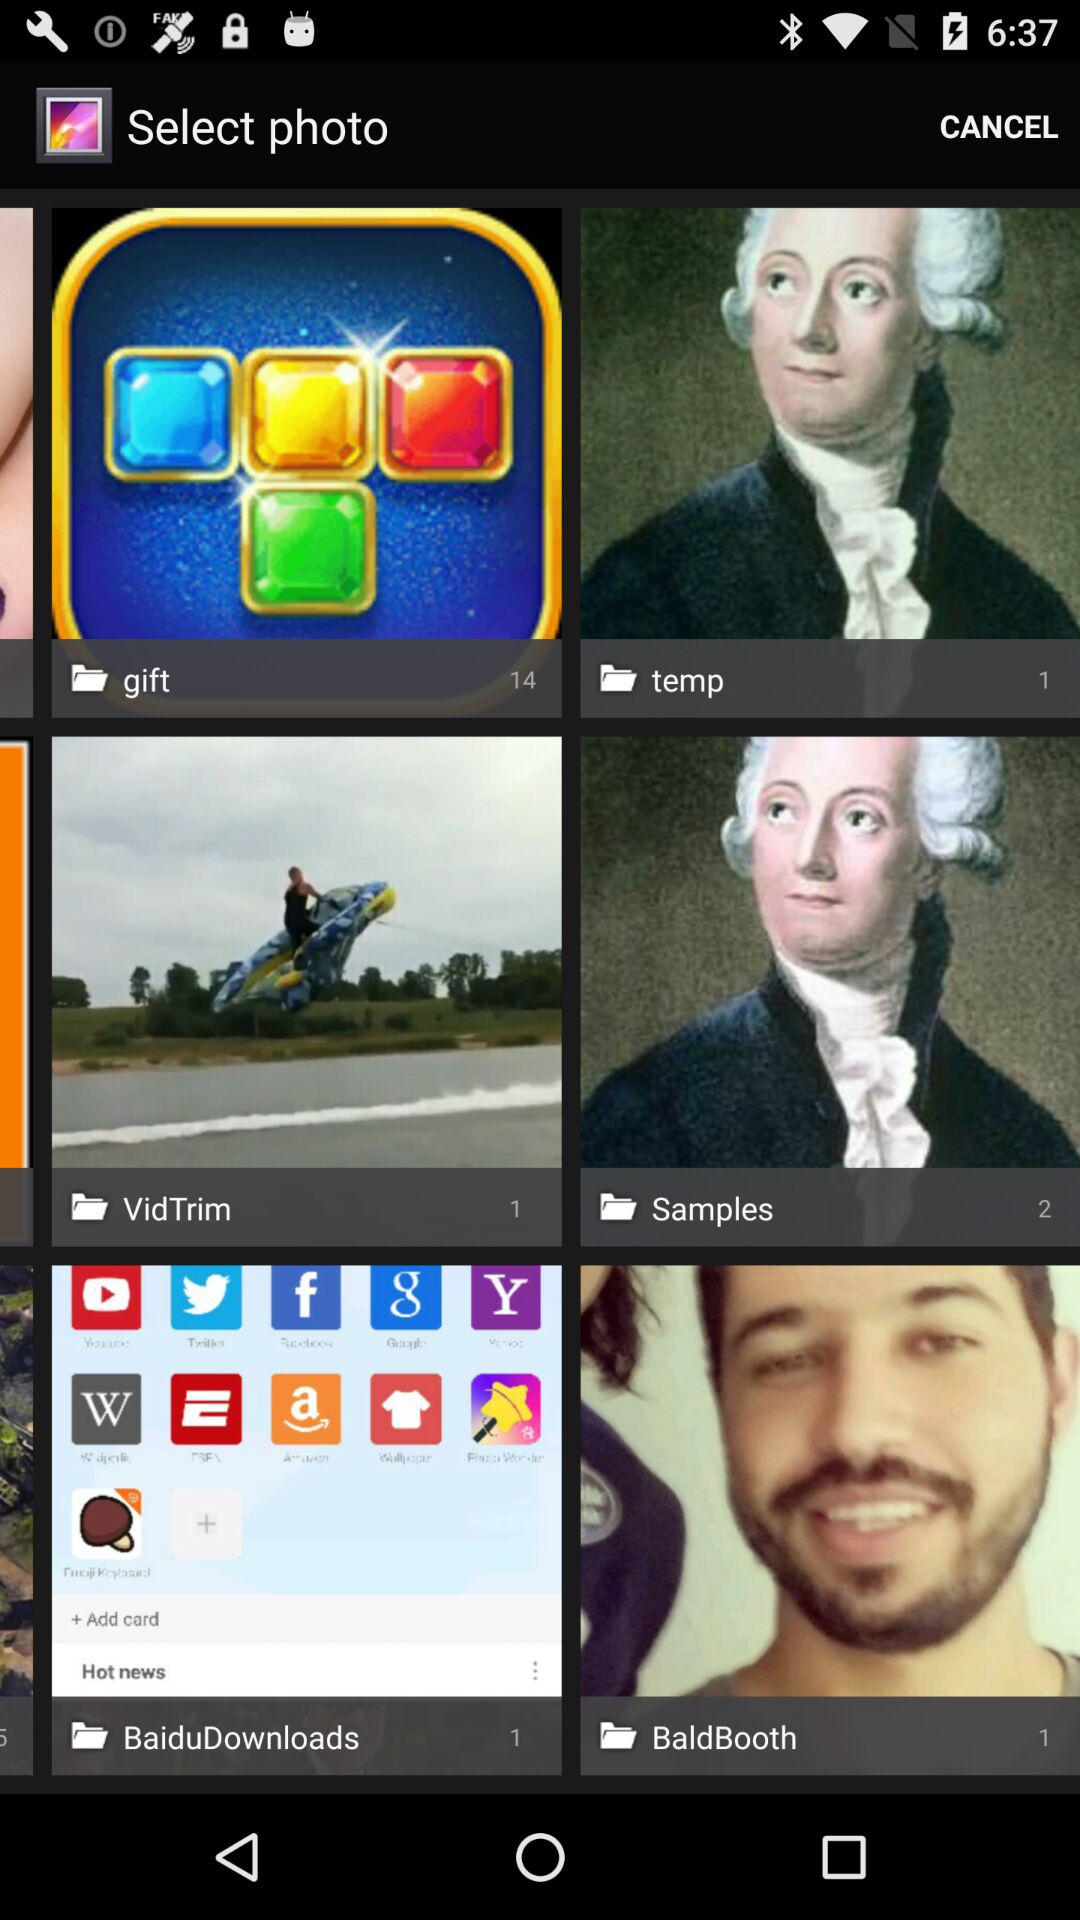How many photos are in the gift folder? There are 14 photos. 